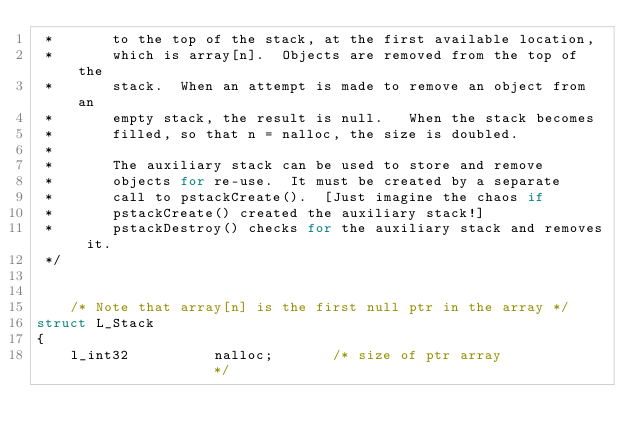Convert code to text. <code><loc_0><loc_0><loc_500><loc_500><_C_> *       to the top of the stack, at the first available location,
 *       which is array[n].  Objects are removed from the top of the
 *       stack.  When an attempt is made to remove an object from an
 *       empty stack, the result is null.   When the stack becomes
 *       filled, so that n = nalloc, the size is doubled.
 *
 *       The auxiliary stack can be used to store and remove
 *       objects for re-use.  It must be created by a separate
 *       call to pstackCreate().  [Just imagine the chaos if
 *       pstackCreate() created the auxiliary stack!]   
 *       pstackDestroy() checks for the auxiliary stack and removes it.
 */


    /* Note that array[n] is the first null ptr in the array */
struct L_Stack
{
    l_int32          nalloc;       /* size of ptr array              */</code> 